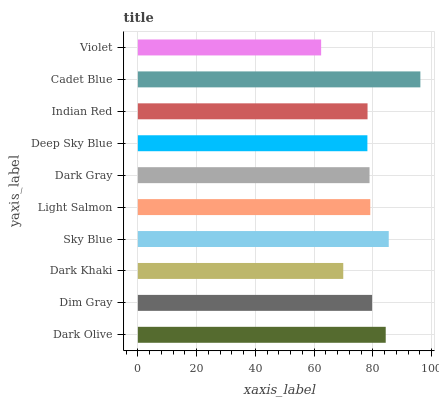Is Violet the minimum?
Answer yes or no. Yes. Is Cadet Blue the maximum?
Answer yes or no. Yes. Is Dim Gray the minimum?
Answer yes or no. No. Is Dim Gray the maximum?
Answer yes or no. No. Is Dark Olive greater than Dim Gray?
Answer yes or no. Yes. Is Dim Gray less than Dark Olive?
Answer yes or no. Yes. Is Dim Gray greater than Dark Olive?
Answer yes or no. No. Is Dark Olive less than Dim Gray?
Answer yes or no. No. Is Light Salmon the high median?
Answer yes or no. Yes. Is Dark Gray the low median?
Answer yes or no. Yes. Is Violet the high median?
Answer yes or no. No. Is Dim Gray the low median?
Answer yes or no. No. 